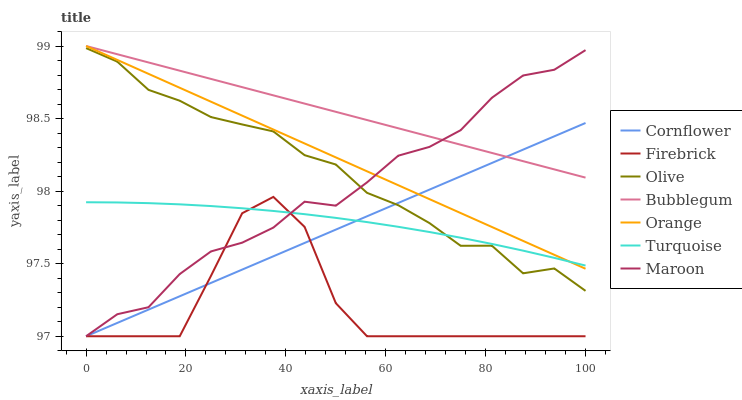Does Firebrick have the minimum area under the curve?
Answer yes or no. Yes. Does Bubblegum have the maximum area under the curve?
Answer yes or no. Yes. Does Turquoise have the minimum area under the curve?
Answer yes or no. No. Does Turquoise have the maximum area under the curve?
Answer yes or no. No. Is Bubblegum the smoothest?
Answer yes or no. Yes. Is Firebrick the roughest?
Answer yes or no. Yes. Is Turquoise the smoothest?
Answer yes or no. No. Is Turquoise the roughest?
Answer yes or no. No. Does Cornflower have the lowest value?
Answer yes or no. Yes. Does Turquoise have the lowest value?
Answer yes or no. No. Does Orange have the highest value?
Answer yes or no. Yes. Does Firebrick have the highest value?
Answer yes or no. No. Is Turquoise less than Bubblegum?
Answer yes or no. Yes. Is Olive greater than Firebrick?
Answer yes or no. Yes. Does Cornflower intersect Olive?
Answer yes or no. Yes. Is Cornflower less than Olive?
Answer yes or no. No. Is Cornflower greater than Olive?
Answer yes or no. No. Does Turquoise intersect Bubblegum?
Answer yes or no. No. 